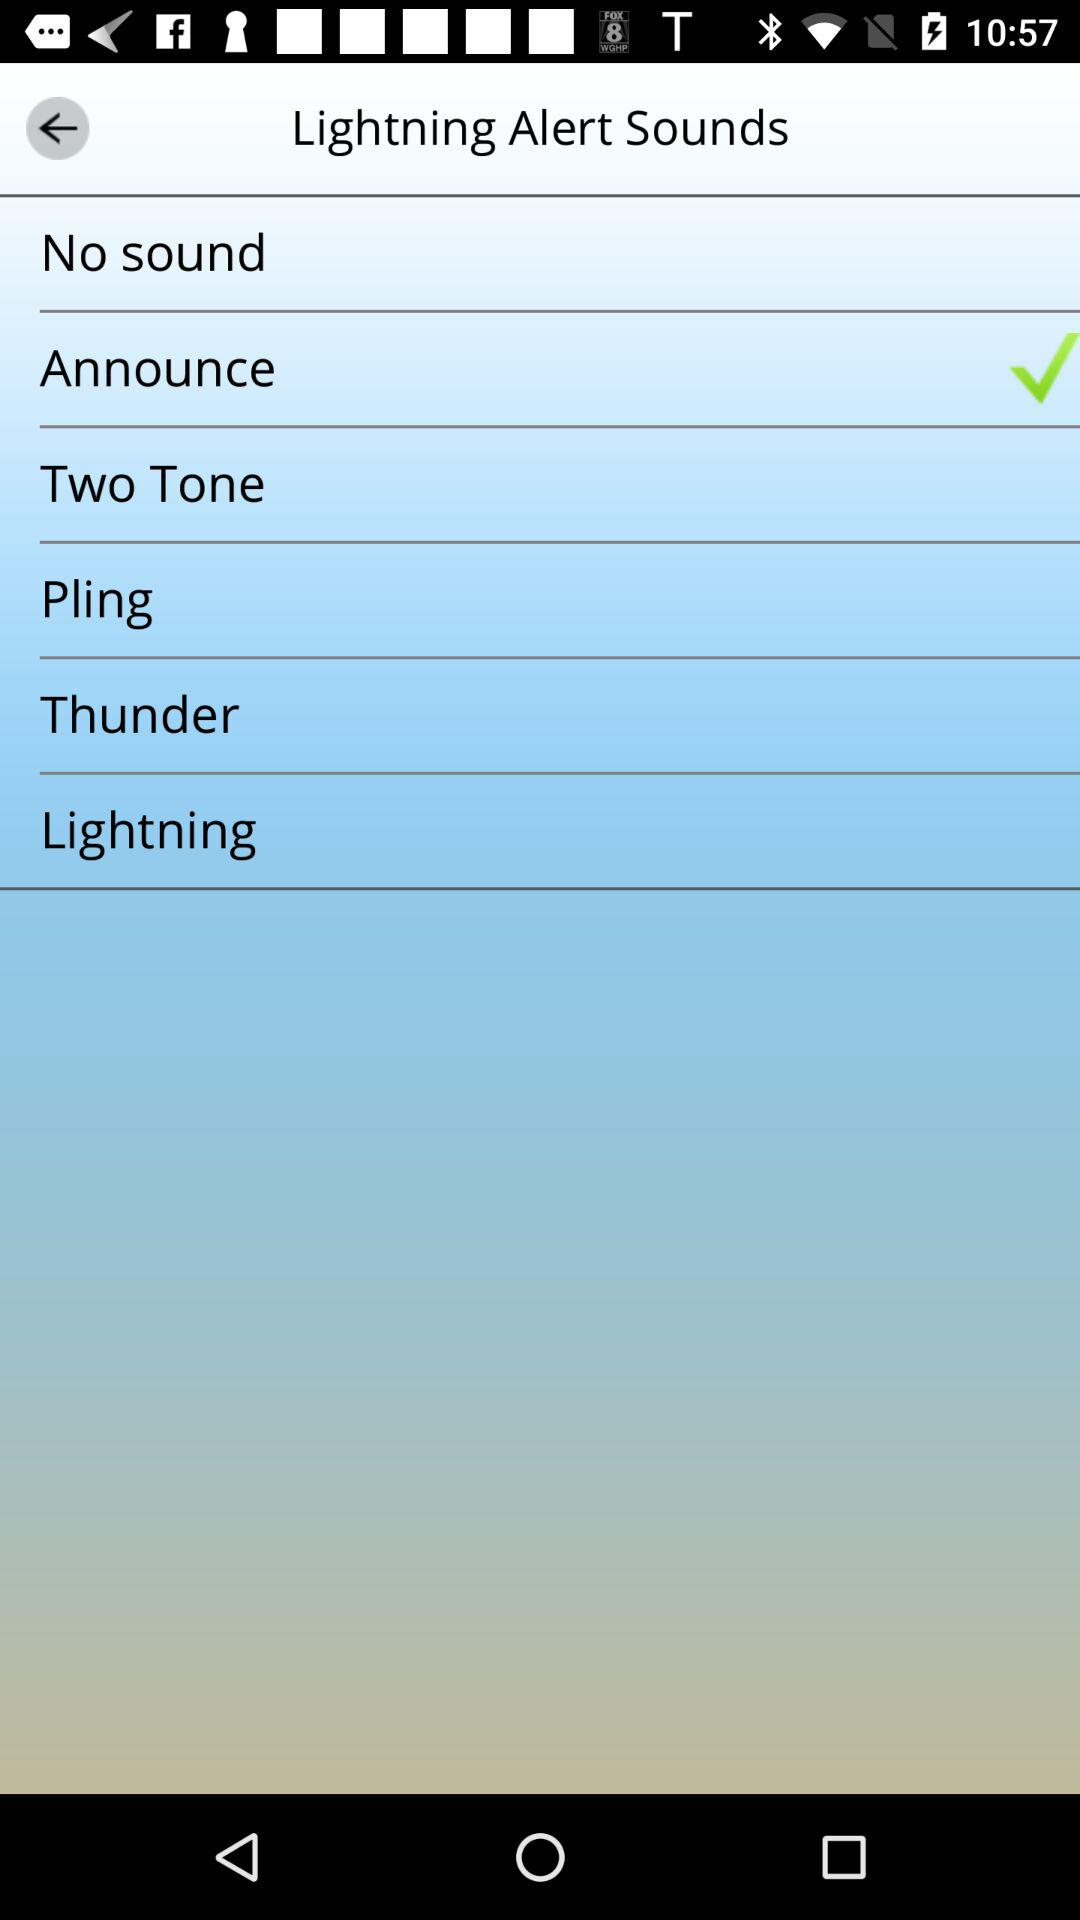Which option is selected? The selected option is "Announce". 